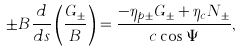Convert formula to latex. <formula><loc_0><loc_0><loc_500><loc_500>\pm B \frac { d } { d s } \left ( \frac { G _ { \pm } } { B } \right ) = \frac { - \eta _ { p \pm } G _ { \pm } + \eta _ { c } N _ { \pm } } { c \cos \Psi } ,</formula> 